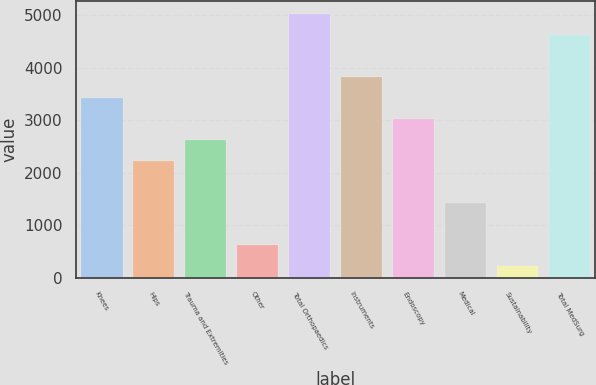Convert chart to OTSL. <chart><loc_0><loc_0><loc_500><loc_500><bar_chart><fcel>Knees<fcel>Hips<fcel>Trauma and Extremities<fcel>Other<fcel>Total Orthopaedics<fcel>Instruments<fcel>Endoscopy<fcel>Medical<fcel>Sustainability<fcel>Total MedSurg<nl><fcel>3421.6<fcel>2219.5<fcel>2620.2<fcel>616.7<fcel>5024.4<fcel>3822.3<fcel>3020.9<fcel>1418.1<fcel>216<fcel>4623.7<nl></chart> 